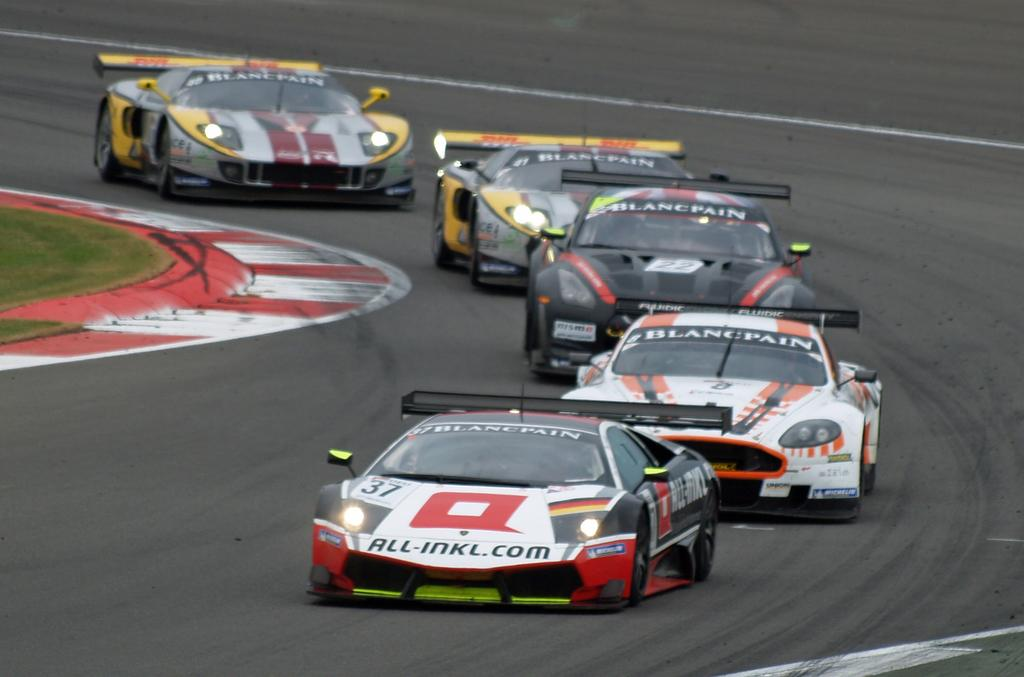What type of vehicles can be seen on the road in the image? There are cars on the road in the image. What can be seen in the background of the image? There is grass visible in the background of the image. Where is the cobweb located in the image? There is no cobweb present in the image. Is it raining in the image? The image does not provide any information about the weather, so we cannot determine if it is raining or not. Can you see a locket in the image? There is no locket present in the image. 